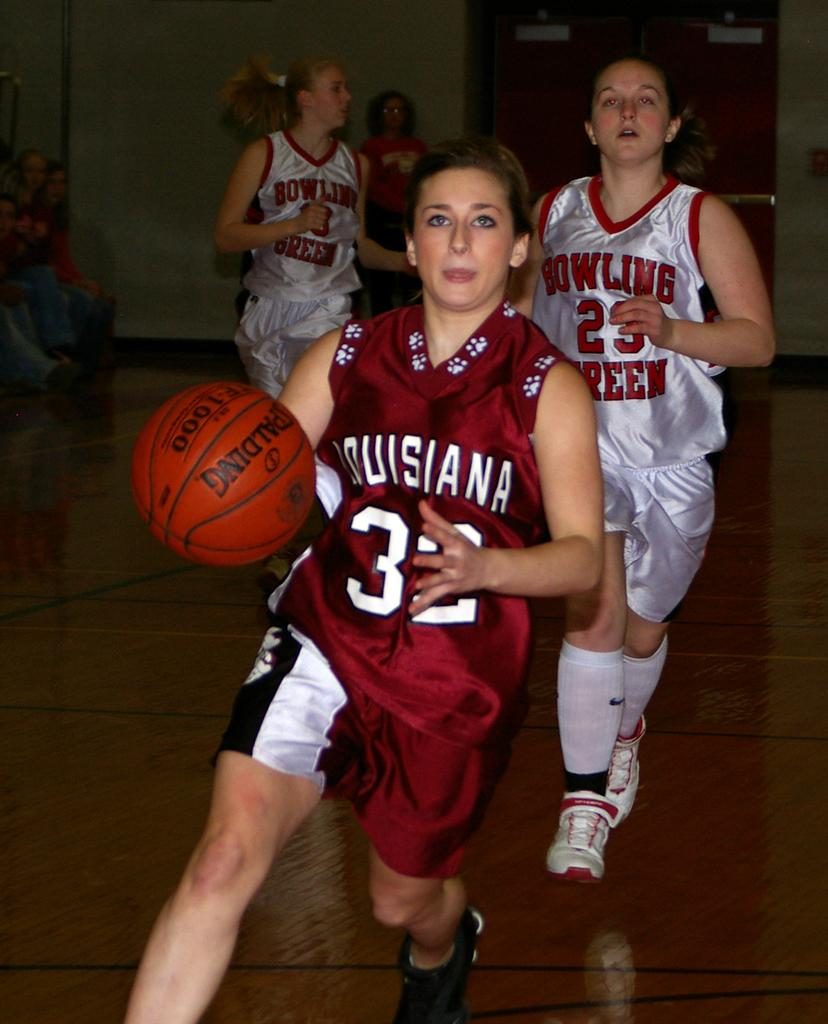<image>
Offer a succinct explanation of the picture presented. Basketball game between Louisiana and the Bowling Greens. 